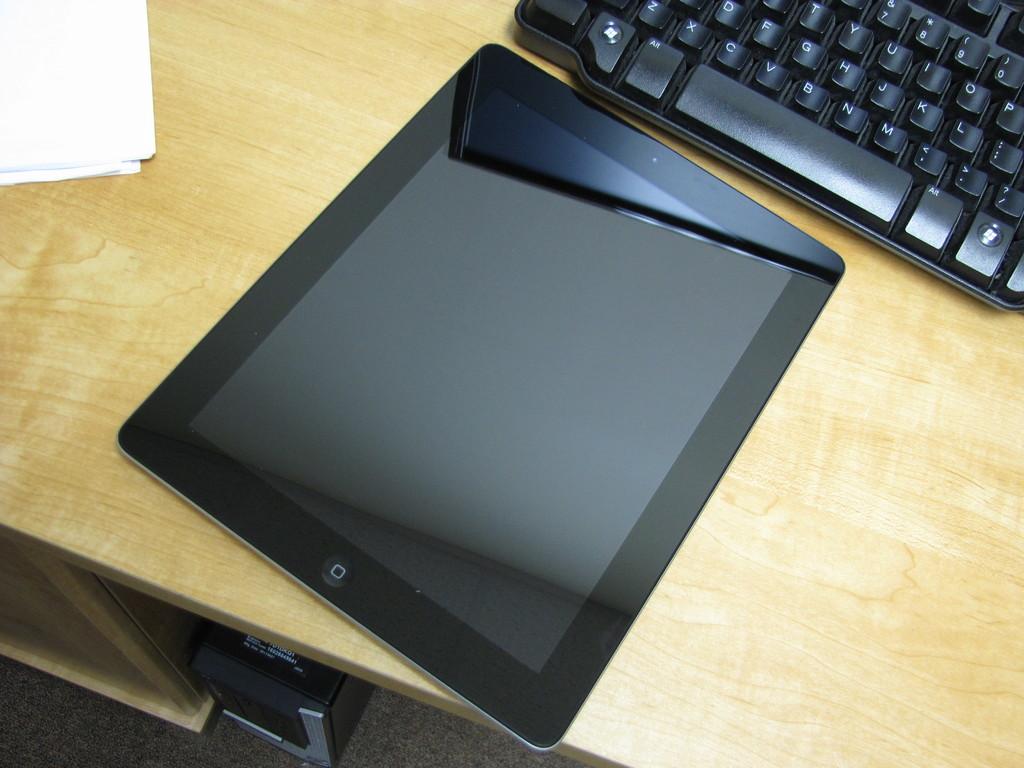What color is the font on the keyboard?
Make the answer very short. Answering does not require reading text in the image. What letter is next to j on the keyboard?
Provide a short and direct response. K. 